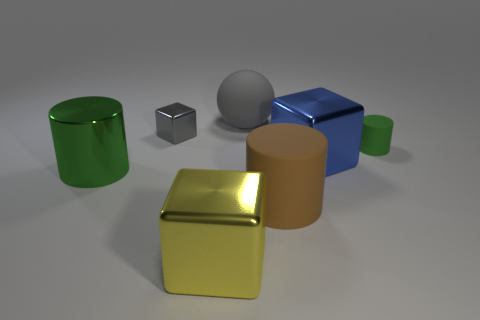There is a tiny object to the right of the large ball; is it the same color as the large cylinder on the left side of the big brown rubber cylinder?
Your response must be concise. Yes. The ball that is the same size as the metallic cylinder is what color?
Ensure brevity in your answer.  Gray. Is there a shiny object of the same color as the sphere?
Give a very brief answer. Yes. Does the cylinder that is left of the brown rubber thing have the same size as the gray shiny thing?
Provide a short and direct response. No. Are there an equal number of large matte things in front of the blue cube and yellow balls?
Make the answer very short. No. What number of objects are either metal cubes in front of the big brown thing or brown things?
Your answer should be compact. 2. What is the shape of the object that is both behind the green matte thing and to the right of the yellow metal object?
Your answer should be compact. Sphere. How many things are big shiny blocks that are in front of the large matte cylinder or objects that are to the left of the yellow block?
Offer a very short reply. 3. What number of other things are there of the same size as the blue metal block?
Offer a terse response. 4. There is a metal block behind the blue metal cube; is it the same color as the sphere?
Give a very brief answer. Yes. 